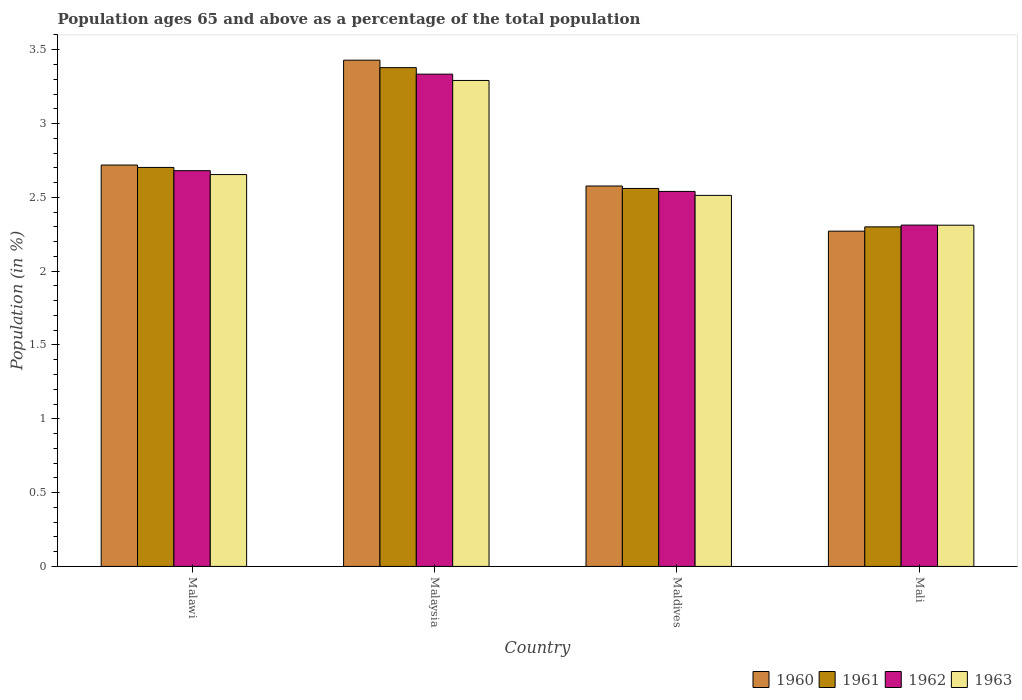How many different coloured bars are there?
Make the answer very short. 4. Are the number of bars on each tick of the X-axis equal?
Give a very brief answer. Yes. How many bars are there on the 2nd tick from the right?
Your answer should be compact. 4. What is the label of the 4th group of bars from the left?
Your response must be concise. Mali. What is the percentage of the population ages 65 and above in 1960 in Malaysia?
Offer a terse response. 3.43. Across all countries, what is the maximum percentage of the population ages 65 and above in 1962?
Ensure brevity in your answer.  3.33. Across all countries, what is the minimum percentage of the population ages 65 and above in 1963?
Your response must be concise. 2.31. In which country was the percentage of the population ages 65 and above in 1963 maximum?
Offer a terse response. Malaysia. In which country was the percentage of the population ages 65 and above in 1960 minimum?
Make the answer very short. Mali. What is the total percentage of the population ages 65 and above in 1963 in the graph?
Your response must be concise. 10.77. What is the difference between the percentage of the population ages 65 and above in 1961 in Malaysia and that in Maldives?
Offer a terse response. 0.82. What is the difference between the percentage of the population ages 65 and above in 1962 in Malaysia and the percentage of the population ages 65 and above in 1963 in Maldives?
Give a very brief answer. 0.82. What is the average percentage of the population ages 65 and above in 1962 per country?
Make the answer very short. 2.72. What is the difference between the percentage of the population ages 65 and above of/in 1963 and percentage of the population ages 65 and above of/in 1962 in Maldives?
Your answer should be compact. -0.03. What is the ratio of the percentage of the population ages 65 and above in 1960 in Malawi to that in Mali?
Your response must be concise. 1.2. Is the percentage of the population ages 65 and above in 1962 in Malaysia less than that in Maldives?
Your response must be concise. No. Is the difference between the percentage of the population ages 65 and above in 1963 in Malawi and Malaysia greater than the difference between the percentage of the population ages 65 and above in 1962 in Malawi and Malaysia?
Offer a very short reply. Yes. What is the difference between the highest and the second highest percentage of the population ages 65 and above in 1961?
Provide a succinct answer. -0.14. What is the difference between the highest and the lowest percentage of the population ages 65 and above in 1963?
Make the answer very short. 0.98. In how many countries, is the percentage of the population ages 65 and above in 1961 greater than the average percentage of the population ages 65 and above in 1961 taken over all countries?
Your answer should be very brief. 1. Is it the case that in every country, the sum of the percentage of the population ages 65 and above in 1963 and percentage of the population ages 65 and above in 1961 is greater than the sum of percentage of the population ages 65 and above in 1962 and percentage of the population ages 65 and above in 1960?
Keep it short and to the point. No. What does the 4th bar from the left in Malaysia represents?
Keep it short and to the point. 1963. What does the 4th bar from the right in Malawi represents?
Your answer should be very brief. 1960. Is it the case that in every country, the sum of the percentage of the population ages 65 and above in 1961 and percentage of the population ages 65 and above in 1960 is greater than the percentage of the population ages 65 and above in 1963?
Keep it short and to the point. Yes. What is the difference between two consecutive major ticks on the Y-axis?
Ensure brevity in your answer.  0.5. Does the graph contain grids?
Make the answer very short. No. Where does the legend appear in the graph?
Provide a short and direct response. Bottom right. How many legend labels are there?
Your response must be concise. 4. What is the title of the graph?
Your answer should be compact. Population ages 65 and above as a percentage of the total population. What is the label or title of the X-axis?
Offer a terse response. Country. What is the label or title of the Y-axis?
Keep it short and to the point. Population (in %). What is the Population (in %) in 1960 in Malawi?
Provide a short and direct response. 2.72. What is the Population (in %) in 1961 in Malawi?
Make the answer very short. 2.7. What is the Population (in %) in 1962 in Malawi?
Your response must be concise. 2.68. What is the Population (in %) of 1963 in Malawi?
Your answer should be compact. 2.65. What is the Population (in %) of 1960 in Malaysia?
Offer a very short reply. 3.43. What is the Population (in %) of 1961 in Malaysia?
Your answer should be compact. 3.38. What is the Population (in %) of 1962 in Malaysia?
Ensure brevity in your answer.  3.33. What is the Population (in %) of 1963 in Malaysia?
Your answer should be very brief. 3.29. What is the Population (in %) in 1960 in Maldives?
Your response must be concise. 2.58. What is the Population (in %) in 1961 in Maldives?
Provide a short and direct response. 2.56. What is the Population (in %) in 1962 in Maldives?
Your answer should be very brief. 2.54. What is the Population (in %) of 1963 in Maldives?
Provide a succinct answer. 2.51. What is the Population (in %) of 1960 in Mali?
Ensure brevity in your answer.  2.27. What is the Population (in %) in 1961 in Mali?
Keep it short and to the point. 2.3. What is the Population (in %) of 1962 in Mali?
Offer a very short reply. 2.31. What is the Population (in %) of 1963 in Mali?
Your answer should be compact. 2.31. Across all countries, what is the maximum Population (in %) of 1960?
Offer a terse response. 3.43. Across all countries, what is the maximum Population (in %) in 1961?
Your answer should be very brief. 3.38. Across all countries, what is the maximum Population (in %) in 1962?
Offer a very short reply. 3.33. Across all countries, what is the maximum Population (in %) of 1963?
Give a very brief answer. 3.29. Across all countries, what is the minimum Population (in %) in 1960?
Your answer should be compact. 2.27. Across all countries, what is the minimum Population (in %) in 1961?
Your response must be concise. 2.3. Across all countries, what is the minimum Population (in %) in 1962?
Your answer should be compact. 2.31. Across all countries, what is the minimum Population (in %) of 1963?
Ensure brevity in your answer.  2.31. What is the total Population (in %) in 1960 in the graph?
Provide a short and direct response. 11. What is the total Population (in %) of 1961 in the graph?
Give a very brief answer. 10.94. What is the total Population (in %) in 1962 in the graph?
Keep it short and to the point. 10.87. What is the total Population (in %) in 1963 in the graph?
Make the answer very short. 10.77. What is the difference between the Population (in %) of 1960 in Malawi and that in Malaysia?
Your answer should be very brief. -0.71. What is the difference between the Population (in %) in 1961 in Malawi and that in Malaysia?
Your answer should be very brief. -0.68. What is the difference between the Population (in %) of 1962 in Malawi and that in Malaysia?
Your answer should be very brief. -0.65. What is the difference between the Population (in %) of 1963 in Malawi and that in Malaysia?
Your answer should be compact. -0.64. What is the difference between the Population (in %) in 1960 in Malawi and that in Maldives?
Provide a succinct answer. 0.14. What is the difference between the Population (in %) of 1961 in Malawi and that in Maldives?
Give a very brief answer. 0.14. What is the difference between the Population (in %) in 1962 in Malawi and that in Maldives?
Keep it short and to the point. 0.14. What is the difference between the Population (in %) in 1963 in Malawi and that in Maldives?
Offer a terse response. 0.14. What is the difference between the Population (in %) in 1960 in Malawi and that in Mali?
Offer a terse response. 0.45. What is the difference between the Population (in %) of 1961 in Malawi and that in Mali?
Offer a very short reply. 0.4. What is the difference between the Population (in %) in 1962 in Malawi and that in Mali?
Keep it short and to the point. 0.37. What is the difference between the Population (in %) of 1963 in Malawi and that in Mali?
Provide a succinct answer. 0.34. What is the difference between the Population (in %) in 1960 in Malaysia and that in Maldives?
Provide a succinct answer. 0.85. What is the difference between the Population (in %) in 1961 in Malaysia and that in Maldives?
Make the answer very short. 0.82. What is the difference between the Population (in %) in 1962 in Malaysia and that in Maldives?
Give a very brief answer. 0.79. What is the difference between the Population (in %) in 1963 in Malaysia and that in Maldives?
Your answer should be very brief. 0.78. What is the difference between the Population (in %) of 1960 in Malaysia and that in Mali?
Provide a succinct answer. 1.16. What is the difference between the Population (in %) of 1961 in Malaysia and that in Mali?
Your response must be concise. 1.08. What is the difference between the Population (in %) in 1962 in Malaysia and that in Mali?
Ensure brevity in your answer.  1.02. What is the difference between the Population (in %) of 1963 in Malaysia and that in Mali?
Offer a very short reply. 0.98. What is the difference between the Population (in %) in 1960 in Maldives and that in Mali?
Make the answer very short. 0.31. What is the difference between the Population (in %) in 1961 in Maldives and that in Mali?
Give a very brief answer. 0.26. What is the difference between the Population (in %) in 1962 in Maldives and that in Mali?
Keep it short and to the point. 0.23. What is the difference between the Population (in %) of 1963 in Maldives and that in Mali?
Your answer should be very brief. 0.2. What is the difference between the Population (in %) of 1960 in Malawi and the Population (in %) of 1961 in Malaysia?
Provide a short and direct response. -0.66. What is the difference between the Population (in %) of 1960 in Malawi and the Population (in %) of 1962 in Malaysia?
Keep it short and to the point. -0.62. What is the difference between the Population (in %) in 1960 in Malawi and the Population (in %) in 1963 in Malaysia?
Offer a very short reply. -0.57. What is the difference between the Population (in %) in 1961 in Malawi and the Population (in %) in 1962 in Malaysia?
Your answer should be very brief. -0.63. What is the difference between the Population (in %) of 1961 in Malawi and the Population (in %) of 1963 in Malaysia?
Make the answer very short. -0.59. What is the difference between the Population (in %) of 1962 in Malawi and the Population (in %) of 1963 in Malaysia?
Give a very brief answer. -0.61. What is the difference between the Population (in %) in 1960 in Malawi and the Population (in %) in 1961 in Maldives?
Offer a terse response. 0.16. What is the difference between the Population (in %) of 1960 in Malawi and the Population (in %) of 1962 in Maldives?
Give a very brief answer. 0.18. What is the difference between the Population (in %) of 1960 in Malawi and the Population (in %) of 1963 in Maldives?
Give a very brief answer. 0.21. What is the difference between the Population (in %) of 1961 in Malawi and the Population (in %) of 1962 in Maldives?
Make the answer very short. 0.16. What is the difference between the Population (in %) of 1961 in Malawi and the Population (in %) of 1963 in Maldives?
Keep it short and to the point. 0.19. What is the difference between the Population (in %) of 1962 in Malawi and the Population (in %) of 1963 in Maldives?
Provide a short and direct response. 0.17. What is the difference between the Population (in %) of 1960 in Malawi and the Population (in %) of 1961 in Mali?
Give a very brief answer. 0.42. What is the difference between the Population (in %) of 1960 in Malawi and the Population (in %) of 1962 in Mali?
Keep it short and to the point. 0.41. What is the difference between the Population (in %) of 1960 in Malawi and the Population (in %) of 1963 in Mali?
Give a very brief answer. 0.41. What is the difference between the Population (in %) of 1961 in Malawi and the Population (in %) of 1962 in Mali?
Offer a very short reply. 0.39. What is the difference between the Population (in %) in 1961 in Malawi and the Population (in %) in 1963 in Mali?
Provide a succinct answer. 0.39. What is the difference between the Population (in %) in 1962 in Malawi and the Population (in %) in 1963 in Mali?
Provide a short and direct response. 0.37. What is the difference between the Population (in %) of 1960 in Malaysia and the Population (in %) of 1961 in Maldives?
Your response must be concise. 0.87. What is the difference between the Population (in %) of 1960 in Malaysia and the Population (in %) of 1963 in Maldives?
Provide a short and direct response. 0.92. What is the difference between the Population (in %) in 1961 in Malaysia and the Population (in %) in 1962 in Maldives?
Give a very brief answer. 0.84. What is the difference between the Population (in %) of 1961 in Malaysia and the Population (in %) of 1963 in Maldives?
Make the answer very short. 0.87. What is the difference between the Population (in %) of 1962 in Malaysia and the Population (in %) of 1963 in Maldives?
Your answer should be very brief. 0.82. What is the difference between the Population (in %) of 1960 in Malaysia and the Population (in %) of 1961 in Mali?
Provide a short and direct response. 1.13. What is the difference between the Population (in %) in 1960 in Malaysia and the Population (in %) in 1962 in Mali?
Give a very brief answer. 1.12. What is the difference between the Population (in %) in 1960 in Malaysia and the Population (in %) in 1963 in Mali?
Give a very brief answer. 1.12. What is the difference between the Population (in %) of 1961 in Malaysia and the Population (in %) of 1962 in Mali?
Ensure brevity in your answer.  1.07. What is the difference between the Population (in %) in 1961 in Malaysia and the Population (in %) in 1963 in Mali?
Keep it short and to the point. 1.07. What is the difference between the Population (in %) in 1962 in Malaysia and the Population (in %) in 1963 in Mali?
Give a very brief answer. 1.02. What is the difference between the Population (in %) of 1960 in Maldives and the Population (in %) of 1961 in Mali?
Your answer should be very brief. 0.28. What is the difference between the Population (in %) of 1960 in Maldives and the Population (in %) of 1962 in Mali?
Provide a short and direct response. 0.26. What is the difference between the Population (in %) in 1960 in Maldives and the Population (in %) in 1963 in Mali?
Your response must be concise. 0.27. What is the difference between the Population (in %) in 1961 in Maldives and the Population (in %) in 1962 in Mali?
Offer a terse response. 0.25. What is the difference between the Population (in %) of 1961 in Maldives and the Population (in %) of 1963 in Mali?
Provide a short and direct response. 0.25. What is the difference between the Population (in %) of 1962 in Maldives and the Population (in %) of 1963 in Mali?
Give a very brief answer. 0.23. What is the average Population (in %) in 1960 per country?
Make the answer very short. 2.75. What is the average Population (in %) of 1961 per country?
Your response must be concise. 2.74. What is the average Population (in %) in 1962 per country?
Give a very brief answer. 2.72. What is the average Population (in %) of 1963 per country?
Your answer should be compact. 2.69. What is the difference between the Population (in %) in 1960 and Population (in %) in 1961 in Malawi?
Your answer should be compact. 0.02. What is the difference between the Population (in %) in 1960 and Population (in %) in 1962 in Malawi?
Ensure brevity in your answer.  0.04. What is the difference between the Population (in %) in 1960 and Population (in %) in 1963 in Malawi?
Your answer should be very brief. 0.06. What is the difference between the Population (in %) in 1961 and Population (in %) in 1962 in Malawi?
Keep it short and to the point. 0.02. What is the difference between the Population (in %) of 1961 and Population (in %) of 1963 in Malawi?
Keep it short and to the point. 0.05. What is the difference between the Population (in %) in 1962 and Population (in %) in 1963 in Malawi?
Offer a terse response. 0.03. What is the difference between the Population (in %) of 1960 and Population (in %) of 1961 in Malaysia?
Your response must be concise. 0.05. What is the difference between the Population (in %) in 1960 and Population (in %) in 1962 in Malaysia?
Keep it short and to the point. 0.09. What is the difference between the Population (in %) of 1960 and Population (in %) of 1963 in Malaysia?
Keep it short and to the point. 0.14. What is the difference between the Population (in %) in 1961 and Population (in %) in 1962 in Malaysia?
Give a very brief answer. 0.04. What is the difference between the Population (in %) in 1961 and Population (in %) in 1963 in Malaysia?
Provide a short and direct response. 0.09. What is the difference between the Population (in %) in 1962 and Population (in %) in 1963 in Malaysia?
Ensure brevity in your answer.  0.04. What is the difference between the Population (in %) in 1960 and Population (in %) in 1961 in Maldives?
Provide a succinct answer. 0.02. What is the difference between the Population (in %) of 1960 and Population (in %) of 1962 in Maldives?
Your response must be concise. 0.04. What is the difference between the Population (in %) of 1960 and Population (in %) of 1963 in Maldives?
Your answer should be very brief. 0.06. What is the difference between the Population (in %) of 1961 and Population (in %) of 1962 in Maldives?
Make the answer very short. 0.02. What is the difference between the Population (in %) in 1961 and Population (in %) in 1963 in Maldives?
Keep it short and to the point. 0.05. What is the difference between the Population (in %) in 1962 and Population (in %) in 1963 in Maldives?
Give a very brief answer. 0.03. What is the difference between the Population (in %) of 1960 and Population (in %) of 1961 in Mali?
Keep it short and to the point. -0.03. What is the difference between the Population (in %) in 1960 and Population (in %) in 1962 in Mali?
Make the answer very short. -0.04. What is the difference between the Population (in %) of 1960 and Population (in %) of 1963 in Mali?
Your response must be concise. -0.04. What is the difference between the Population (in %) in 1961 and Population (in %) in 1962 in Mali?
Your response must be concise. -0.01. What is the difference between the Population (in %) of 1961 and Population (in %) of 1963 in Mali?
Give a very brief answer. -0.01. What is the difference between the Population (in %) of 1962 and Population (in %) of 1963 in Mali?
Make the answer very short. 0. What is the ratio of the Population (in %) of 1960 in Malawi to that in Malaysia?
Your response must be concise. 0.79. What is the ratio of the Population (in %) in 1961 in Malawi to that in Malaysia?
Offer a very short reply. 0.8. What is the ratio of the Population (in %) of 1962 in Malawi to that in Malaysia?
Your response must be concise. 0.8. What is the ratio of the Population (in %) of 1963 in Malawi to that in Malaysia?
Provide a succinct answer. 0.81. What is the ratio of the Population (in %) of 1960 in Malawi to that in Maldives?
Your answer should be compact. 1.06. What is the ratio of the Population (in %) in 1961 in Malawi to that in Maldives?
Offer a very short reply. 1.06. What is the ratio of the Population (in %) of 1962 in Malawi to that in Maldives?
Make the answer very short. 1.06. What is the ratio of the Population (in %) in 1963 in Malawi to that in Maldives?
Your response must be concise. 1.06. What is the ratio of the Population (in %) in 1960 in Malawi to that in Mali?
Offer a terse response. 1.2. What is the ratio of the Population (in %) of 1961 in Malawi to that in Mali?
Provide a succinct answer. 1.18. What is the ratio of the Population (in %) in 1962 in Malawi to that in Mali?
Make the answer very short. 1.16. What is the ratio of the Population (in %) of 1963 in Malawi to that in Mali?
Your response must be concise. 1.15. What is the ratio of the Population (in %) of 1960 in Malaysia to that in Maldives?
Offer a very short reply. 1.33. What is the ratio of the Population (in %) in 1961 in Malaysia to that in Maldives?
Your answer should be compact. 1.32. What is the ratio of the Population (in %) in 1962 in Malaysia to that in Maldives?
Offer a very short reply. 1.31. What is the ratio of the Population (in %) of 1963 in Malaysia to that in Maldives?
Make the answer very short. 1.31. What is the ratio of the Population (in %) in 1960 in Malaysia to that in Mali?
Keep it short and to the point. 1.51. What is the ratio of the Population (in %) in 1961 in Malaysia to that in Mali?
Provide a short and direct response. 1.47. What is the ratio of the Population (in %) of 1962 in Malaysia to that in Mali?
Provide a succinct answer. 1.44. What is the ratio of the Population (in %) of 1963 in Malaysia to that in Mali?
Provide a short and direct response. 1.42. What is the ratio of the Population (in %) of 1960 in Maldives to that in Mali?
Provide a short and direct response. 1.13. What is the ratio of the Population (in %) of 1961 in Maldives to that in Mali?
Provide a succinct answer. 1.11. What is the ratio of the Population (in %) in 1962 in Maldives to that in Mali?
Your answer should be compact. 1.1. What is the ratio of the Population (in %) in 1963 in Maldives to that in Mali?
Offer a terse response. 1.09. What is the difference between the highest and the second highest Population (in %) in 1960?
Offer a very short reply. 0.71. What is the difference between the highest and the second highest Population (in %) in 1961?
Make the answer very short. 0.68. What is the difference between the highest and the second highest Population (in %) of 1962?
Your answer should be compact. 0.65. What is the difference between the highest and the second highest Population (in %) of 1963?
Offer a terse response. 0.64. What is the difference between the highest and the lowest Population (in %) in 1960?
Your response must be concise. 1.16. What is the difference between the highest and the lowest Population (in %) of 1961?
Ensure brevity in your answer.  1.08. What is the difference between the highest and the lowest Population (in %) of 1962?
Your answer should be compact. 1.02. What is the difference between the highest and the lowest Population (in %) in 1963?
Ensure brevity in your answer.  0.98. 